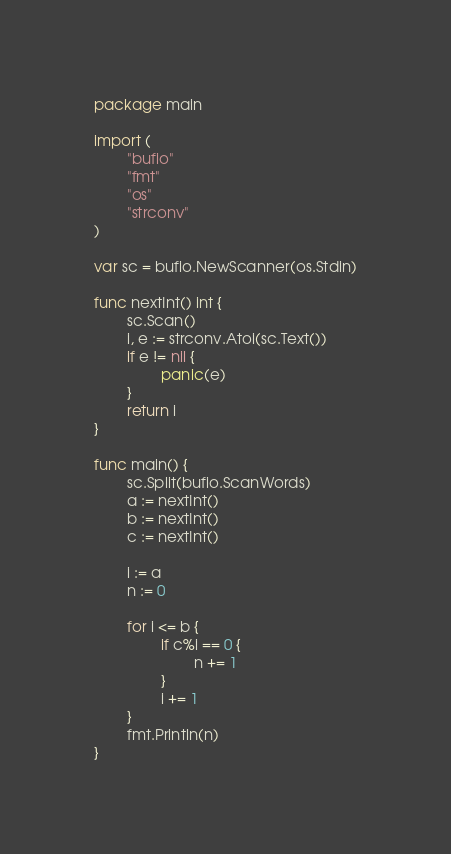<code> <loc_0><loc_0><loc_500><loc_500><_Go_>package main

import (
        "bufio"
        "fmt"
        "os"
        "strconv"
)

var sc = bufio.NewScanner(os.Stdin)

func nextInt() int {
        sc.Scan()
        i, e := strconv.Atoi(sc.Text())
        if e != nil {
                panic(e)
        }
        return i
}

func main() {
        sc.Split(bufio.ScanWords)
        a := nextInt()
        b := nextInt()
        c := nextInt()

        i := a
        n := 0

        for i <= b {
                if c%i == 0 {
                        n += 1
                }
                i += 1
        }
        fmt.Println(n)
}
</code> 